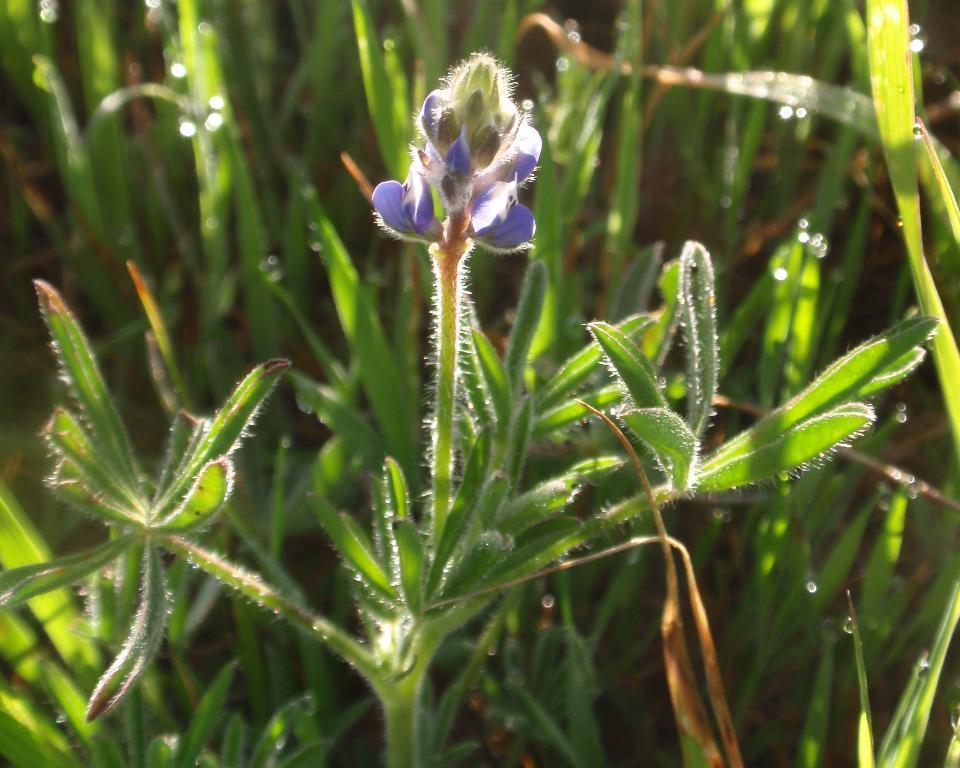In one or two sentences, can you explain what this image depicts? This image consists of plants. In the front, we can see a flower in blue color. The leaves are in green color. 